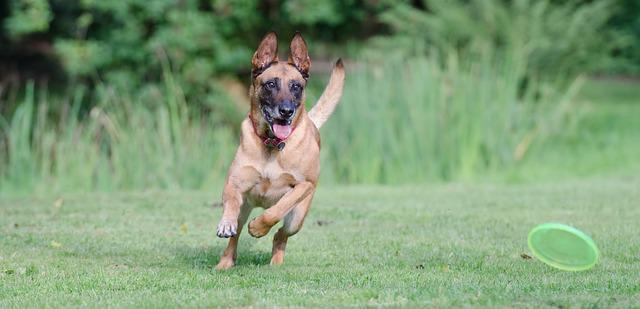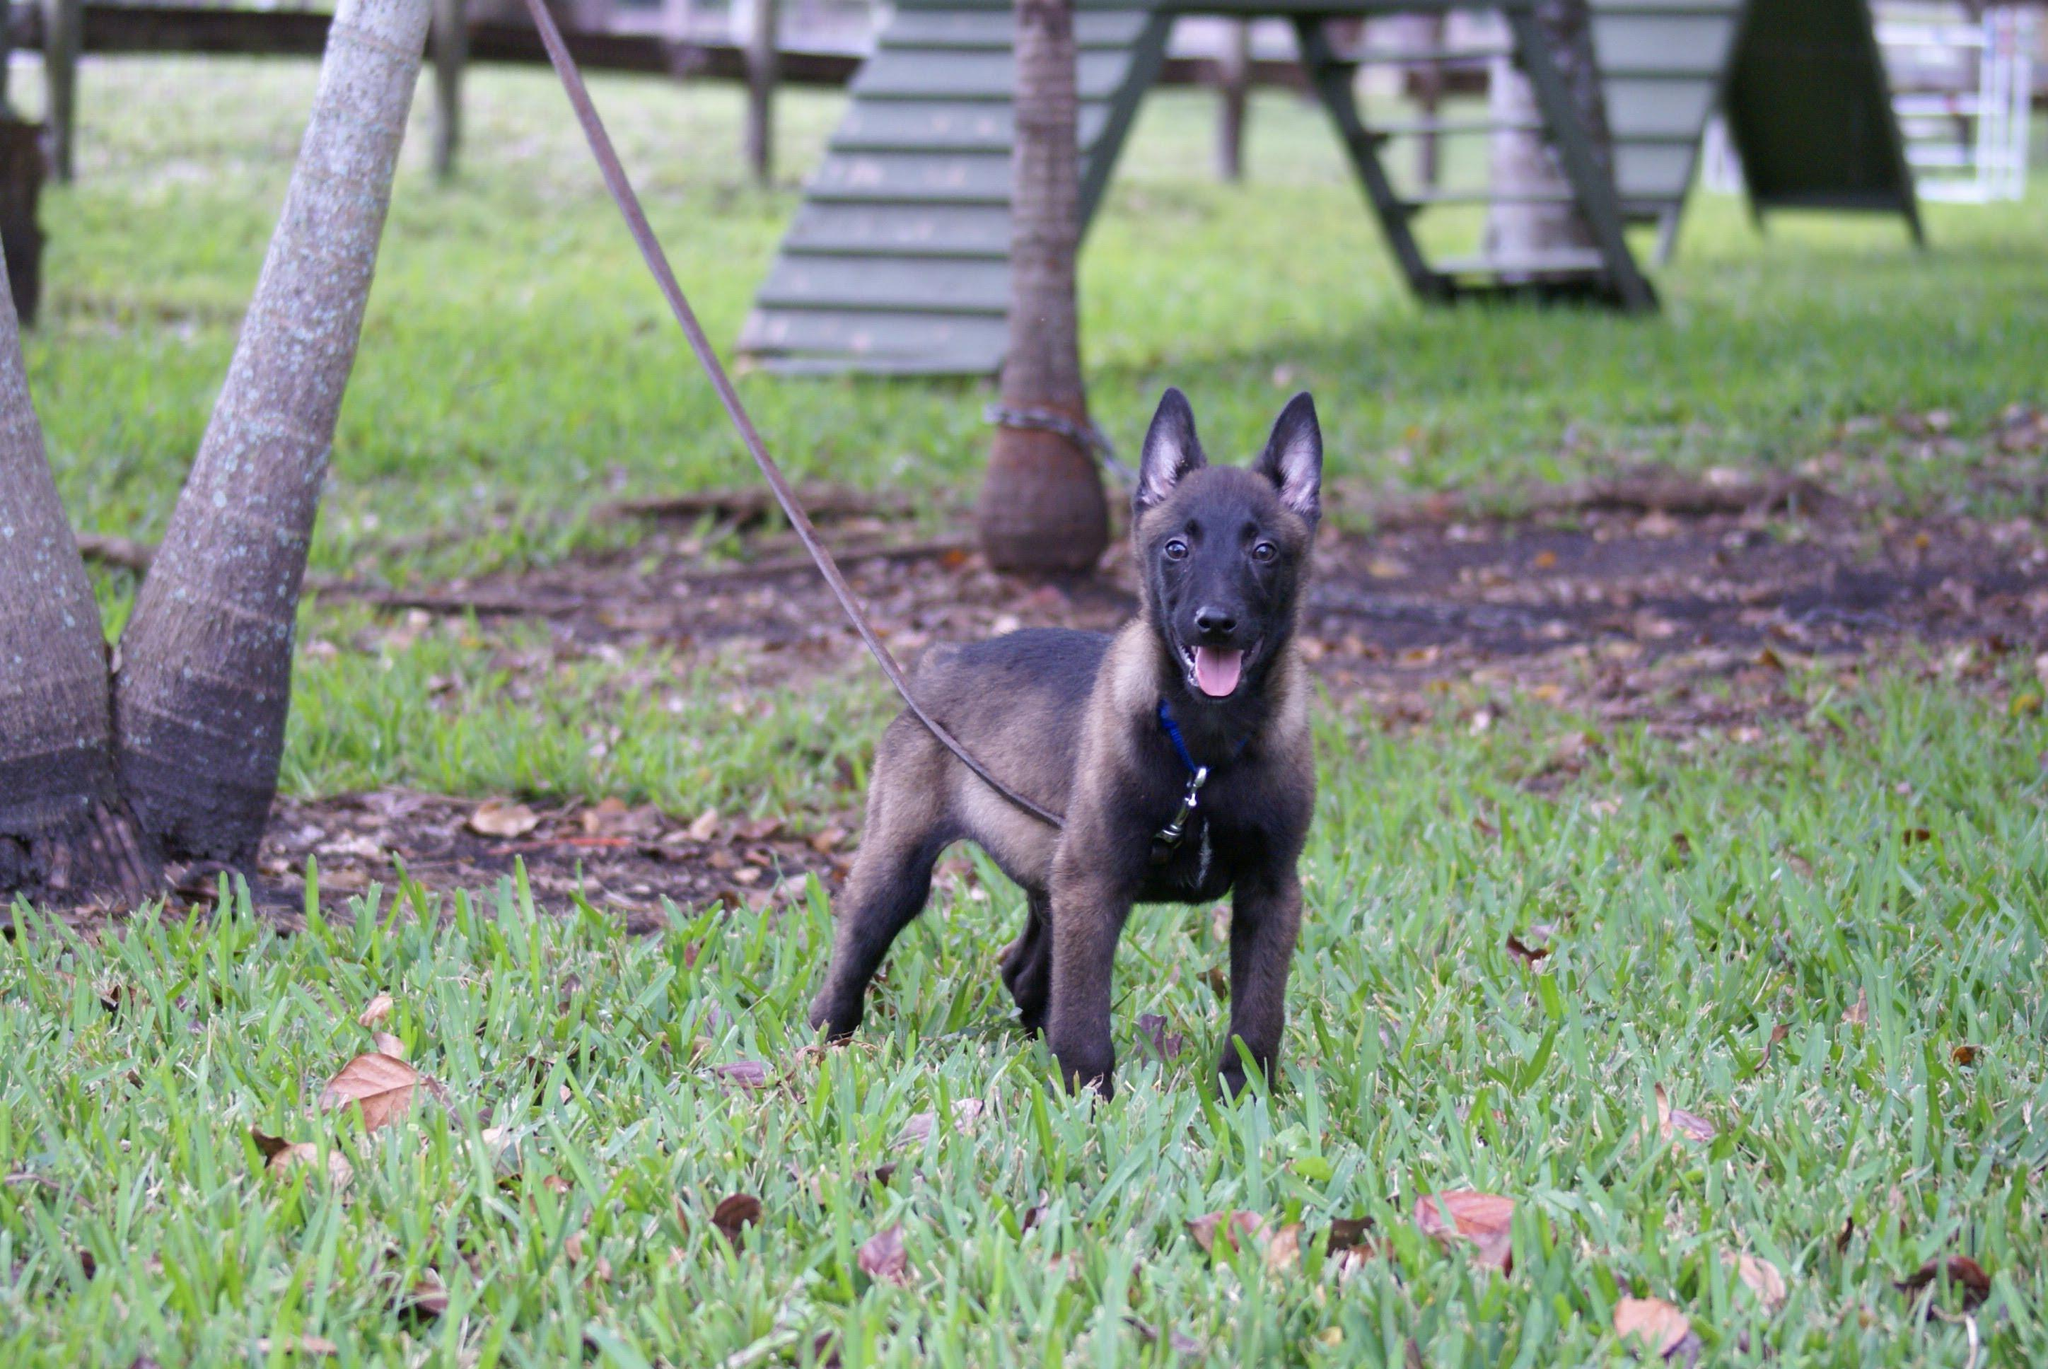The first image is the image on the left, the second image is the image on the right. For the images displayed, is the sentence "In one image od each pair a lone dog is standing still on grass." factually correct? Answer yes or no. Yes. The first image is the image on the left, the second image is the image on the right. For the images shown, is this caption "There is one dog standing still on all fours in the stacked position." true? Answer yes or no. Yes. 